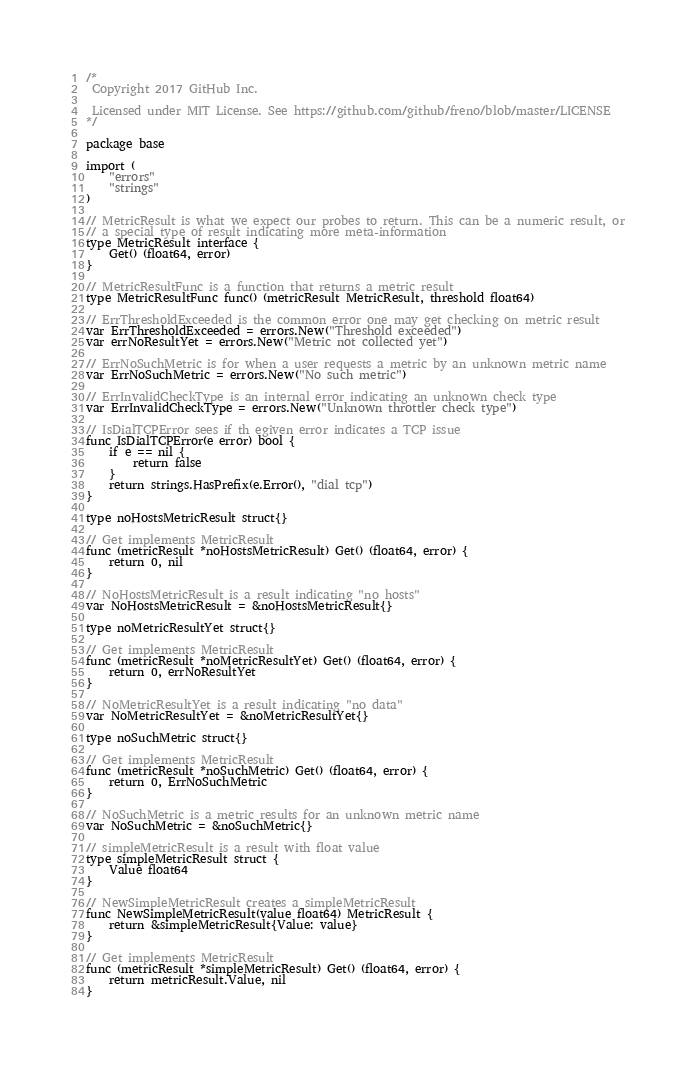Convert code to text. <code><loc_0><loc_0><loc_500><loc_500><_Go_>/*
 Copyright 2017 GitHub Inc.

 Licensed under MIT License. See https://github.com/github/freno/blob/master/LICENSE
*/

package base

import (
	"errors"
	"strings"
)

// MetricResult is what we expect our probes to return. This can be a numeric result, or
// a special type of result indicating more meta-information
type MetricResult interface {
	Get() (float64, error)
}

// MetricResultFunc is a function that returns a metric result
type MetricResultFunc func() (metricResult MetricResult, threshold float64)

// ErrThresholdExceeded is the common error one may get checking on metric result
var ErrThresholdExceeded = errors.New("Threshold exceeded")
var errNoResultYet = errors.New("Metric not collected yet")

// ErrNoSuchMetric is for when a user requests a metric by an unknown metric name
var ErrNoSuchMetric = errors.New("No such metric")

// ErrInvalidCheckType is an internal error indicating an unknown check type
var ErrInvalidCheckType = errors.New("Unknown throttler check type")

// IsDialTCPError sees if th egiven error indicates a TCP issue
func IsDialTCPError(e error) bool {
	if e == nil {
		return false
	}
	return strings.HasPrefix(e.Error(), "dial tcp")
}

type noHostsMetricResult struct{}

// Get implements MetricResult
func (metricResult *noHostsMetricResult) Get() (float64, error) {
	return 0, nil
}

// NoHostsMetricResult is a result indicating "no hosts"
var NoHostsMetricResult = &noHostsMetricResult{}

type noMetricResultYet struct{}

// Get implements MetricResult
func (metricResult *noMetricResultYet) Get() (float64, error) {
	return 0, errNoResultYet
}

// NoMetricResultYet is a result indicating "no data"
var NoMetricResultYet = &noMetricResultYet{}

type noSuchMetric struct{}

// Get implements MetricResult
func (metricResult *noSuchMetric) Get() (float64, error) {
	return 0, ErrNoSuchMetric
}

// NoSuchMetric is a metric results for an unknown metric name
var NoSuchMetric = &noSuchMetric{}

// simpleMetricResult is a result with float value
type simpleMetricResult struct {
	Value float64
}

// NewSimpleMetricResult creates a simpleMetricResult
func NewSimpleMetricResult(value float64) MetricResult {
	return &simpleMetricResult{Value: value}
}

// Get implements MetricResult
func (metricResult *simpleMetricResult) Get() (float64, error) {
	return metricResult.Value, nil
}
</code> 